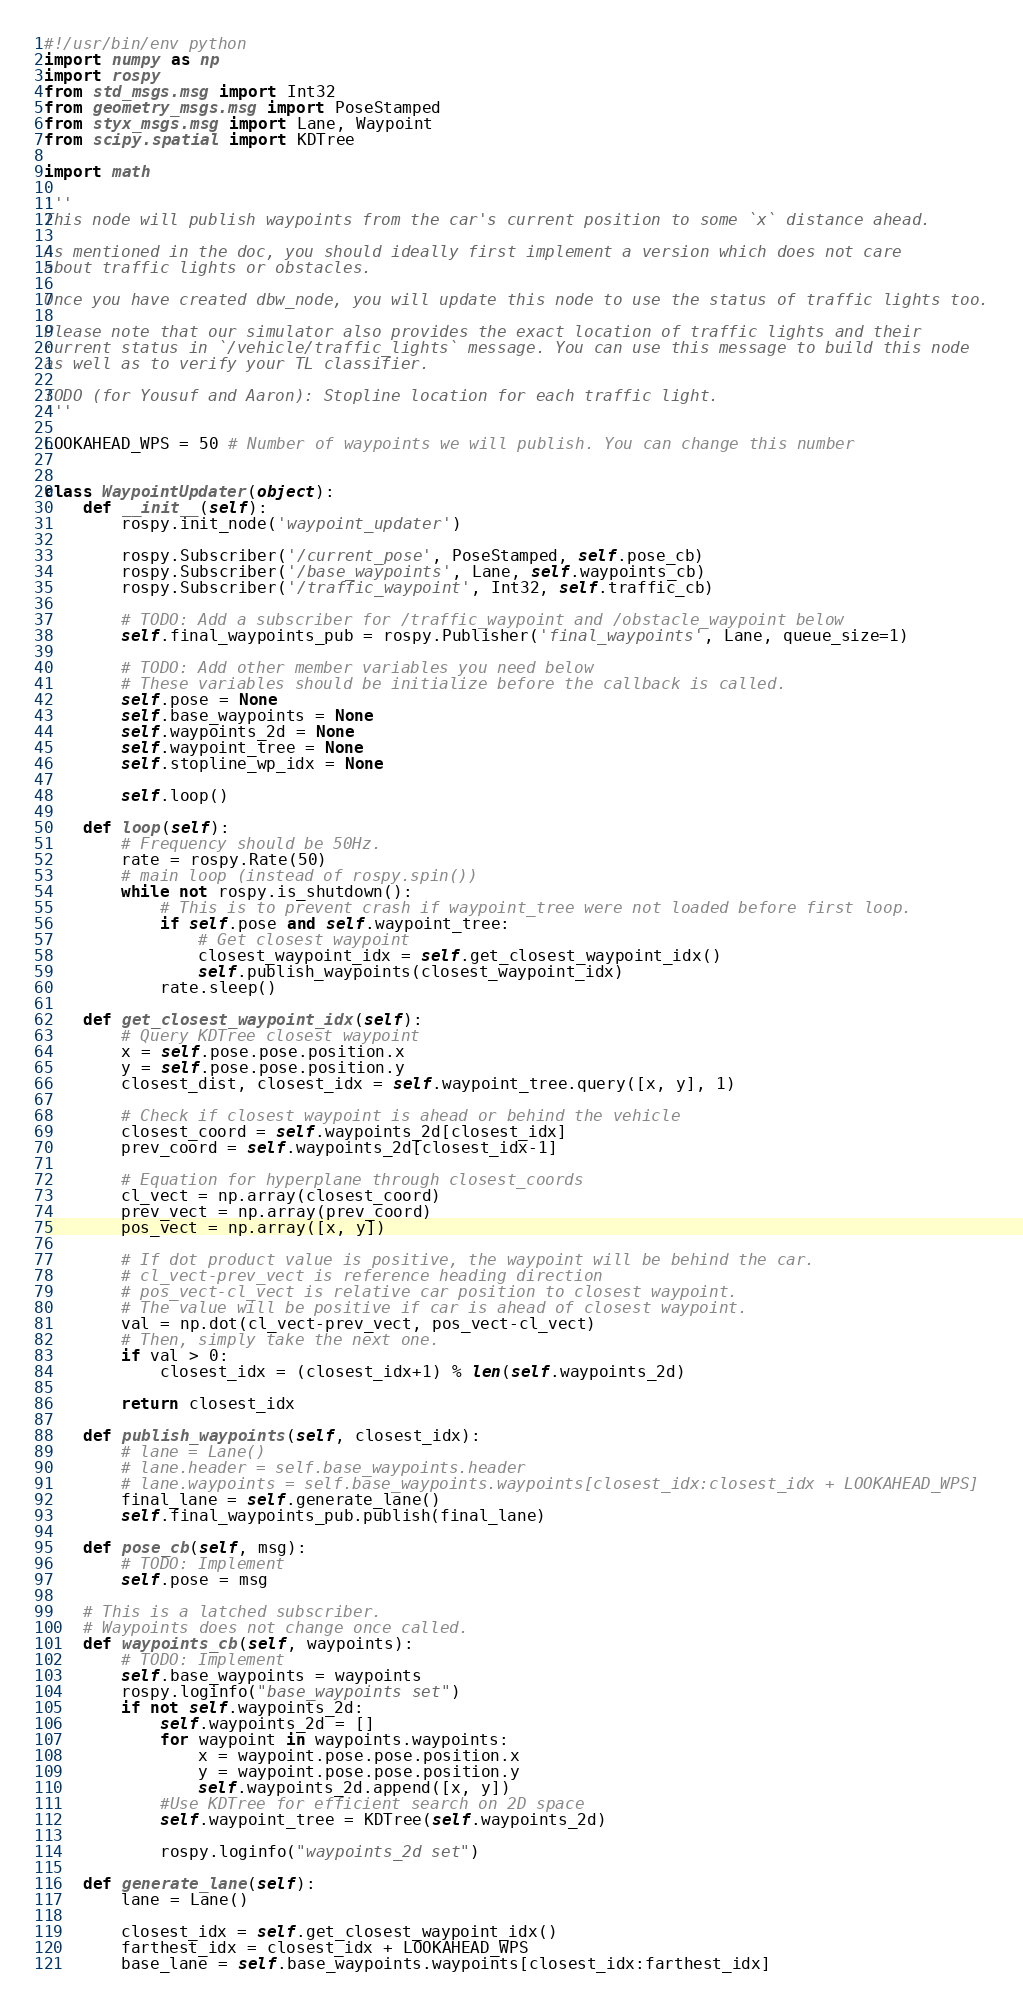<code> <loc_0><loc_0><loc_500><loc_500><_Python_>#!/usr/bin/env python
import numpy as np
import rospy
from std_msgs.msg import Int32
from geometry_msgs.msg import PoseStamped
from styx_msgs.msg import Lane, Waypoint
from scipy.spatial import KDTree

import math

'''
This node will publish waypoints from the car's current position to some `x` distance ahead.

As mentioned in the doc, you should ideally first implement a version which does not care
about traffic lights or obstacles.

Once you have created dbw_node, you will update this node to use the status of traffic lights too.

Please note that our simulator also provides the exact location of traffic lights and their
current status in `/vehicle/traffic_lights` message. You can use this message to build this node
as well as to verify your TL classifier.

TODO (for Yousuf and Aaron): Stopline location for each traffic light.
'''

LOOKAHEAD_WPS = 50 # Number of waypoints we will publish. You can change this number


class WaypointUpdater(object):
    def __init__(self):
        rospy.init_node('waypoint_updater')

        rospy.Subscriber('/current_pose', PoseStamped, self.pose_cb)
        rospy.Subscriber('/base_waypoints', Lane, self.waypoints_cb)
        rospy.Subscriber('/traffic_waypoint', Int32, self.traffic_cb)

        # TODO: Add a subscriber for /traffic_waypoint and /obstacle_waypoint below
        self.final_waypoints_pub = rospy.Publisher('final_waypoints', Lane, queue_size=1)

        # TODO: Add other member variables you need below
        # These variables should be initialize before the callback is called.
        self.pose = None
        self.base_waypoints = None
        self.waypoints_2d = None
        self.waypoint_tree = None
        self.stopline_wp_idx = None

        self.loop()

    def loop(self):
        # Frequency should be 50Hz.
        rate = rospy.Rate(50)
        # main loop (instead of rospy.spin())
        while not rospy.is_shutdown(): 
            # This is to prevent crash if waypoint_tree were not loaded before first loop.
            if self.pose and self.waypoint_tree:
                # Get closest waypoint
                closest_waypoint_idx = self.get_closest_waypoint_idx()
                self.publish_waypoints(closest_waypoint_idx)
            rate.sleep()

    def get_closest_waypoint_idx(self):
        # Query KDTree closest waypoint
        x = self.pose.pose.position.x
        y = self.pose.pose.position.y
        closest_dist, closest_idx = self.waypoint_tree.query([x, y], 1)

        # Check if closest waypoint is ahead or behind the vehicle
        closest_coord = self.waypoints_2d[closest_idx]
        prev_coord = self.waypoints_2d[closest_idx-1]

        # Equation for hyperplane through closest_coords
        cl_vect = np.array(closest_coord)
        prev_vect = np.array(prev_coord)
        pos_vect = np.array([x, y])
        
        # If dot product value is positive, the waypoint will be behind the car.
        # cl_vect-prev_vect is reference heading direction
        # pos_vect-cl_vect is relative car position to closest waypoint.
        # The value will be positive if car is ahead of closest waypoint.
        val = np.dot(cl_vect-prev_vect, pos_vect-cl_vect)
        # Then, simply take the next one.
        if val > 0:
            closest_idx = (closest_idx+1) % len(self.waypoints_2d)

        return closest_idx

    def publish_waypoints(self, closest_idx):
        # lane = Lane()
        # lane.header = self.base_waypoints.header
        # lane.waypoints = self.base_waypoints.waypoints[closest_idx:closest_idx + LOOKAHEAD_WPS]
        final_lane = self.generate_lane()
        self.final_waypoints_pub.publish(final_lane)

    def pose_cb(self, msg):
        # TODO: Implement
        self.pose = msg

    # This is a latched subscriber.
    # Waypoints does not change once called.
    def waypoints_cb(self, waypoints):
        # TODO: Implement
        self.base_waypoints = waypoints
        rospy.loginfo("base_waypoints set")
        if not self.waypoints_2d:
            self.waypoints_2d = []
            for waypoint in waypoints.waypoints:
                x = waypoint.pose.pose.position.x
                y = waypoint.pose.pose.position.y
                self.waypoints_2d.append([x, y])
            #Use KDTree for efficient search on 2D space
            self.waypoint_tree = KDTree(self.waypoints_2d) 

            rospy.loginfo("waypoints_2d set")
    
    def generate_lane(self):
        lane = Lane()
        
        closest_idx = self.get_closest_waypoint_idx()
        farthest_idx = closest_idx + LOOKAHEAD_WPS
        base_lane = self.base_waypoints.waypoints[closest_idx:farthest_idx]
</code> 